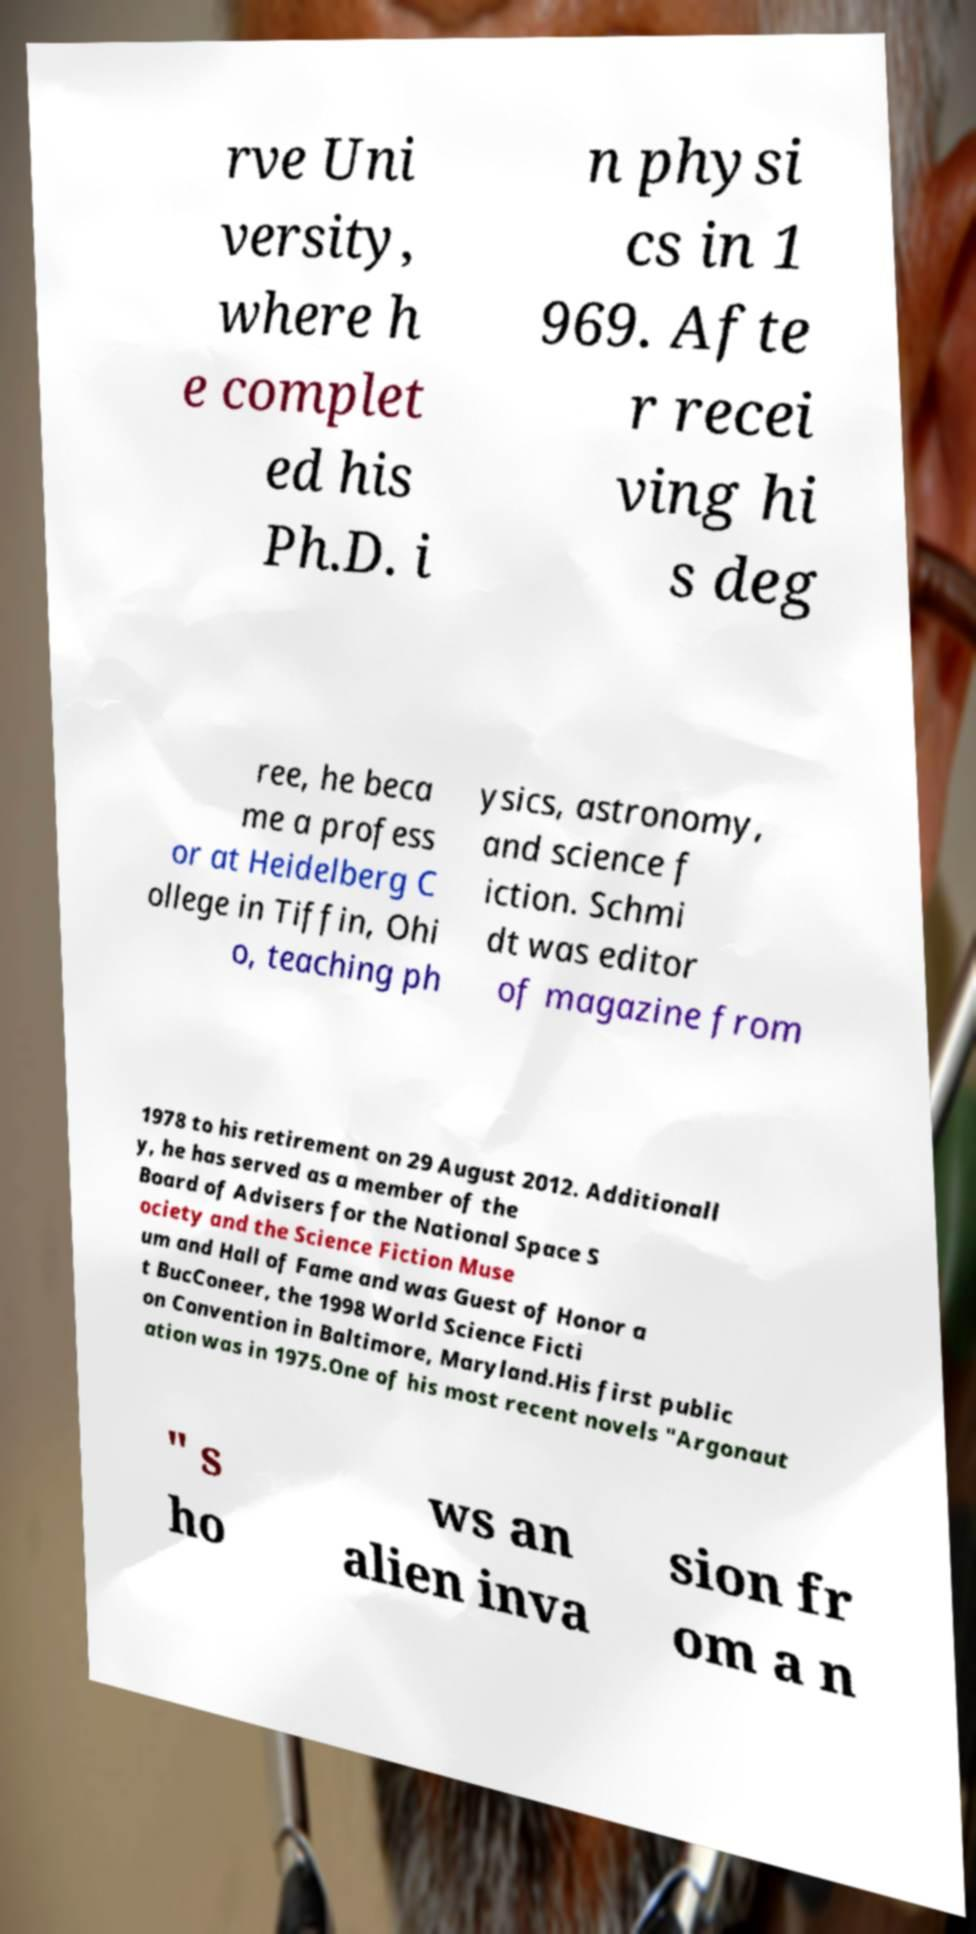Please identify and transcribe the text found in this image. rve Uni versity, where h e complet ed his Ph.D. i n physi cs in 1 969. Afte r recei ving hi s deg ree, he beca me a profess or at Heidelberg C ollege in Tiffin, Ohi o, teaching ph ysics, astronomy, and science f iction. Schmi dt was editor of magazine from 1978 to his retirement on 29 August 2012. Additionall y, he has served as a member of the Board of Advisers for the National Space S ociety and the Science Fiction Muse um and Hall of Fame and was Guest of Honor a t BucConeer, the 1998 World Science Ficti on Convention in Baltimore, Maryland.His first public ation was in 1975.One of his most recent novels "Argonaut " s ho ws an alien inva sion fr om a n 